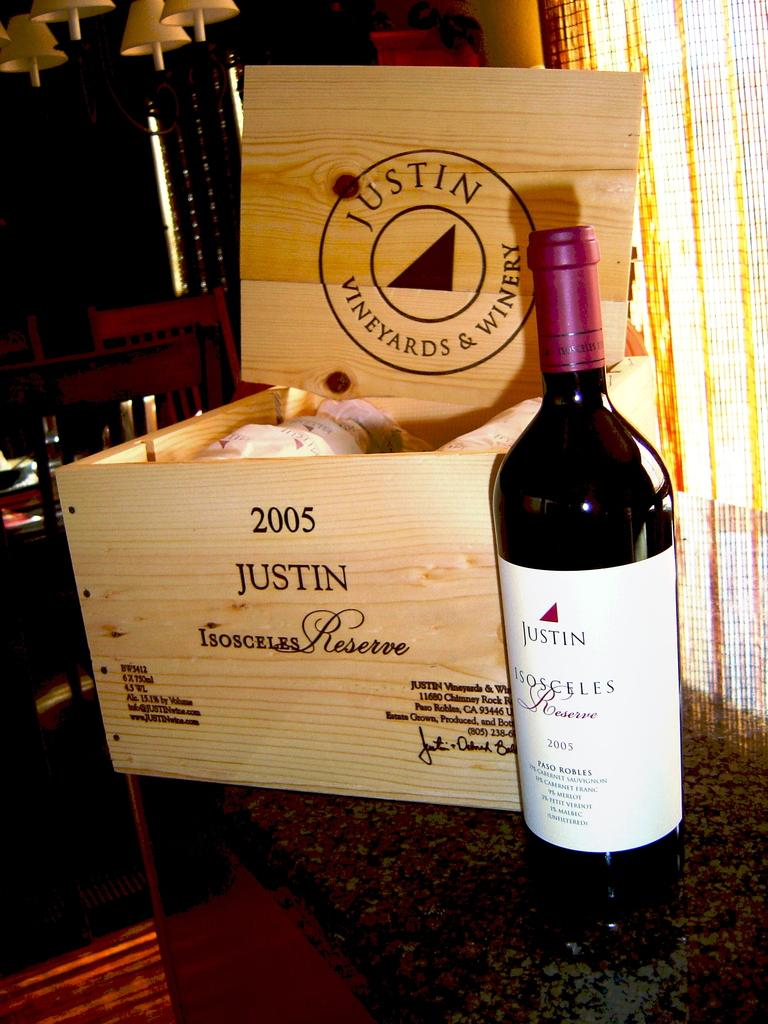Provide a one-sentence caption for the provided image. A bottle of Justin Red wine stands unopened next to a classy wooden wine box. 